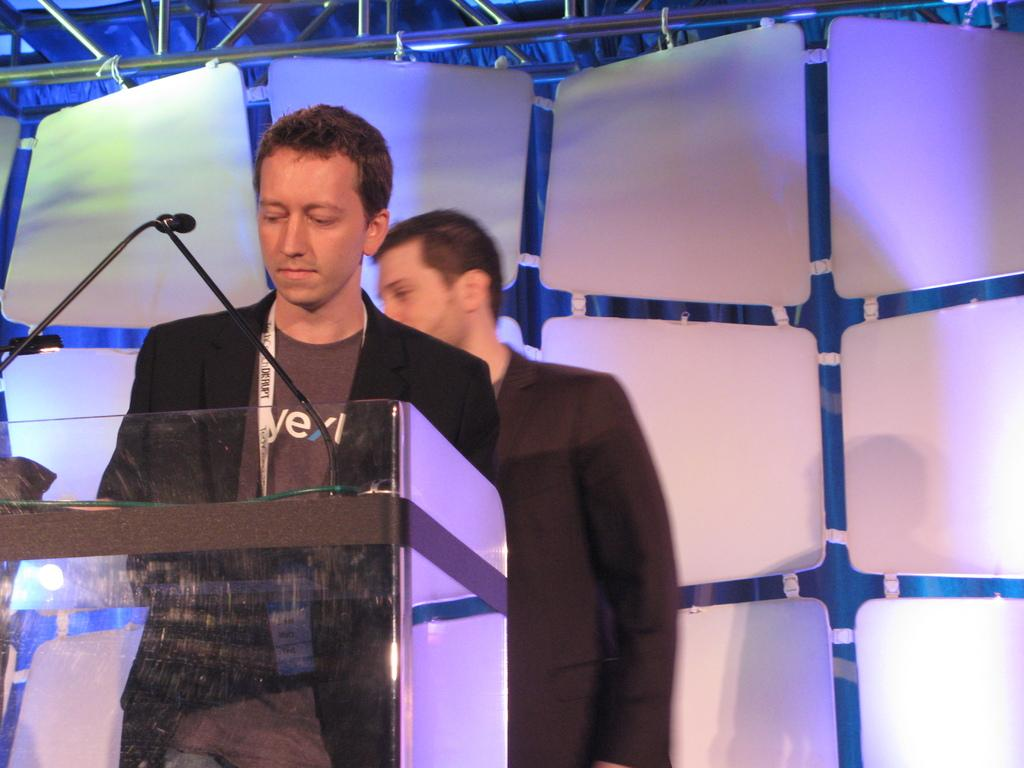What is the main subject of the image? There is a person standing in the image. Can you describe the person's attire? The person is wearing a tag. What is in front of the person? There is a stand with mics in front of the person. Can you describe the background of the image? There is another person in the background of the image, along with rods and curtains. What type of science experiment is being conducted in the image? There is no science experiment present in the image. What color is the apple on the person's head in the image? There is no apple or person with an apple on their head in the image. 